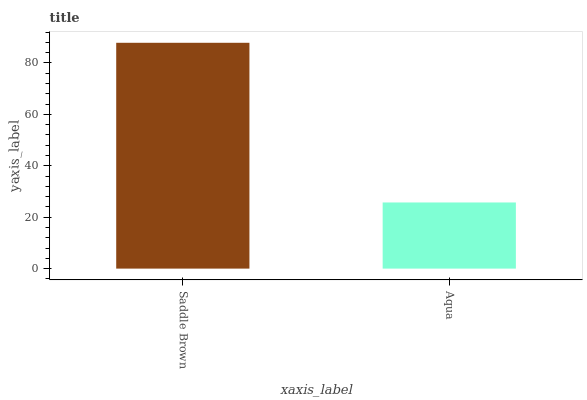Is Aqua the minimum?
Answer yes or no. Yes. Is Saddle Brown the maximum?
Answer yes or no. Yes. Is Aqua the maximum?
Answer yes or no. No. Is Saddle Brown greater than Aqua?
Answer yes or no. Yes. Is Aqua less than Saddle Brown?
Answer yes or no. Yes. Is Aqua greater than Saddle Brown?
Answer yes or no. No. Is Saddle Brown less than Aqua?
Answer yes or no. No. Is Saddle Brown the high median?
Answer yes or no. Yes. Is Aqua the low median?
Answer yes or no. Yes. Is Aqua the high median?
Answer yes or no. No. Is Saddle Brown the low median?
Answer yes or no. No. 